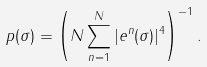Convert formula to latex. <formula><loc_0><loc_0><loc_500><loc_500>p ( \sigma ) = \left ( N \sum _ { n = 1 } ^ { N } | { e } ^ { n } ( \sigma ) | ^ { 4 } \right ) ^ { - 1 } .</formula> 